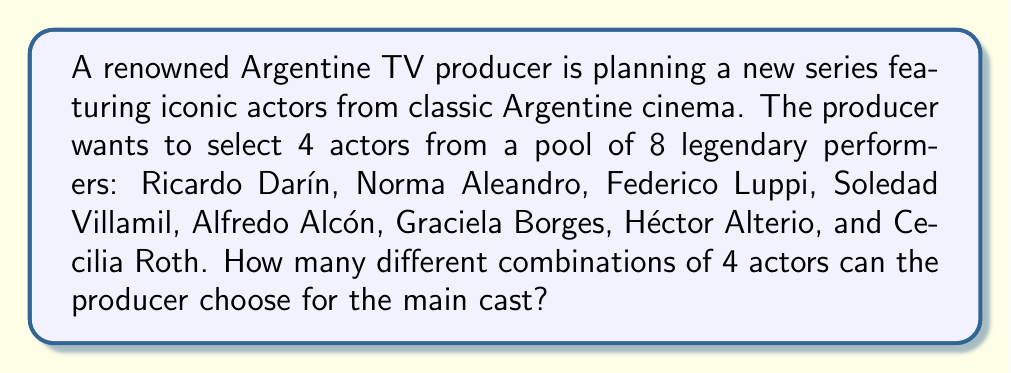Can you solve this math problem? Let's approach this step-by-step:

1) This is a combination problem because the order of selection doesn't matter (it's just about who is in the cast, not their specific roles).

2) We are selecting 4 actors from a total of 8.

3) The formula for combinations is:

   $$C(n,r) = \frac{n!}{r!(n-r)!}$$

   Where $n$ is the total number of items to choose from, and $r$ is the number of items being chosen.

4) In this case, $n = 8$ and $r = 4$

5) Plugging these values into the formula:

   $$C(8,4) = \frac{8!}{4!(8-4)!} = \frac{8!}{4!4!}$$

6) Expand this:
   $$\frac{8 \times 7 \times 6 \times 5 \times 4!}{4! \times 4 \times 3 \times 2 \times 1}$$

7) The 4! cancels out in the numerator and denominator:

   $$\frac{8 \times 7 \times 6 \times 5}{4 \times 3 \times 2 \times 1} = \frac{1680}{24} = 70$$

Therefore, the producer can choose 70 different combinations of 4 actors from the 8 legendary performers.
Answer: 70 